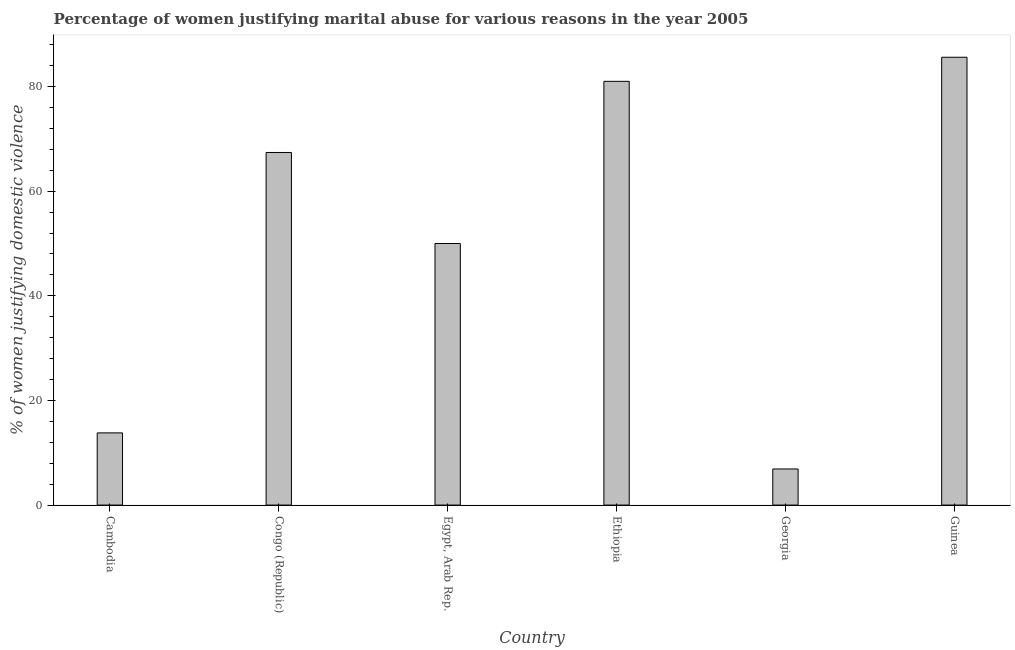Does the graph contain any zero values?
Make the answer very short. No. Does the graph contain grids?
Your answer should be very brief. No. What is the title of the graph?
Ensure brevity in your answer.  Percentage of women justifying marital abuse for various reasons in the year 2005. What is the label or title of the X-axis?
Your answer should be very brief. Country. What is the label or title of the Y-axis?
Offer a terse response. % of women justifying domestic violence. What is the percentage of women justifying marital abuse in Georgia?
Make the answer very short. 6.9. Across all countries, what is the maximum percentage of women justifying marital abuse?
Provide a short and direct response. 85.6. Across all countries, what is the minimum percentage of women justifying marital abuse?
Ensure brevity in your answer.  6.9. In which country was the percentage of women justifying marital abuse maximum?
Give a very brief answer. Guinea. In which country was the percentage of women justifying marital abuse minimum?
Give a very brief answer. Georgia. What is the sum of the percentage of women justifying marital abuse?
Ensure brevity in your answer.  304.7. What is the difference between the percentage of women justifying marital abuse in Congo (Republic) and Egypt, Arab Rep.?
Make the answer very short. 17.4. What is the average percentage of women justifying marital abuse per country?
Your response must be concise. 50.78. What is the median percentage of women justifying marital abuse?
Ensure brevity in your answer.  58.7. What is the ratio of the percentage of women justifying marital abuse in Congo (Republic) to that in Ethiopia?
Your response must be concise. 0.83. Is the percentage of women justifying marital abuse in Congo (Republic) less than that in Egypt, Arab Rep.?
Give a very brief answer. No. What is the difference between the highest and the second highest percentage of women justifying marital abuse?
Provide a succinct answer. 4.6. Is the sum of the percentage of women justifying marital abuse in Egypt, Arab Rep. and Georgia greater than the maximum percentage of women justifying marital abuse across all countries?
Your answer should be compact. No. What is the difference between the highest and the lowest percentage of women justifying marital abuse?
Your answer should be compact. 78.7. Are all the bars in the graph horizontal?
Offer a very short reply. No. How many countries are there in the graph?
Keep it short and to the point. 6. Are the values on the major ticks of Y-axis written in scientific E-notation?
Your answer should be very brief. No. What is the % of women justifying domestic violence of Congo (Republic)?
Offer a very short reply. 67.4. What is the % of women justifying domestic violence of Egypt, Arab Rep.?
Your response must be concise. 50. What is the % of women justifying domestic violence of Ethiopia?
Keep it short and to the point. 81. What is the % of women justifying domestic violence in Guinea?
Offer a terse response. 85.6. What is the difference between the % of women justifying domestic violence in Cambodia and Congo (Republic)?
Offer a very short reply. -53.6. What is the difference between the % of women justifying domestic violence in Cambodia and Egypt, Arab Rep.?
Provide a succinct answer. -36.2. What is the difference between the % of women justifying domestic violence in Cambodia and Ethiopia?
Offer a very short reply. -67.2. What is the difference between the % of women justifying domestic violence in Cambodia and Guinea?
Offer a terse response. -71.8. What is the difference between the % of women justifying domestic violence in Congo (Republic) and Egypt, Arab Rep.?
Provide a succinct answer. 17.4. What is the difference between the % of women justifying domestic violence in Congo (Republic) and Ethiopia?
Give a very brief answer. -13.6. What is the difference between the % of women justifying domestic violence in Congo (Republic) and Georgia?
Offer a terse response. 60.5. What is the difference between the % of women justifying domestic violence in Congo (Republic) and Guinea?
Offer a terse response. -18.2. What is the difference between the % of women justifying domestic violence in Egypt, Arab Rep. and Ethiopia?
Ensure brevity in your answer.  -31. What is the difference between the % of women justifying domestic violence in Egypt, Arab Rep. and Georgia?
Provide a short and direct response. 43.1. What is the difference between the % of women justifying domestic violence in Egypt, Arab Rep. and Guinea?
Your answer should be very brief. -35.6. What is the difference between the % of women justifying domestic violence in Ethiopia and Georgia?
Offer a very short reply. 74.1. What is the difference between the % of women justifying domestic violence in Georgia and Guinea?
Offer a very short reply. -78.7. What is the ratio of the % of women justifying domestic violence in Cambodia to that in Congo (Republic)?
Offer a terse response. 0.2. What is the ratio of the % of women justifying domestic violence in Cambodia to that in Egypt, Arab Rep.?
Your answer should be compact. 0.28. What is the ratio of the % of women justifying domestic violence in Cambodia to that in Ethiopia?
Your response must be concise. 0.17. What is the ratio of the % of women justifying domestic violence in Cambodia to that in Guinea?
Provide a short and direct response. 0.16. What is the ratio of the % of women justifying domestic violence in Congo (Republic) to that in Egypt, Arab Rep.?
Your response must be concise. 1.35. What is the ratio of the % of women justifying domestic violence in Congo (Republic) to that in Ethiopia?
Provide a short and direct response. 0.83. What is the ratio of the % of women justifying domestic violence in Congo (Republic) to that in Georgia?
Give a very brief answer. 9.77. What is the ratio of the % of women justifying domestic violence in Congo (Republic) to that in Guinea?
Provide a succinct answer. 0.79. What is the ratio of the % of women justifying domestic violence in Egypt, Arab Rep. to that in Ethiopia?
Provide a short and direct response. 0.62. What is the ratio of the % of women justifying domestic violence in Egypt, Arab Rep. to that in Georgia?
Keep it short and to the point. 7.25. What is the ratio of the % of women justifying domestic violence in Egypt, Arab Rep. to that in Guinea?
Keep it short and to the point. 0.58. What is the ratio of the % of women justifying domestic violence in Ethiopia to that in Georgia?
Offer a very short reply. 11.74. What is the ratio of the % of women justifying domestic violence in Ethiopia to that in Guinea?
Offer a very short reply. 0.95. What is the ratio of the % of women justifying domestic violence in Georgia to that in Guinea?
Offer a terse response. 0.08. 